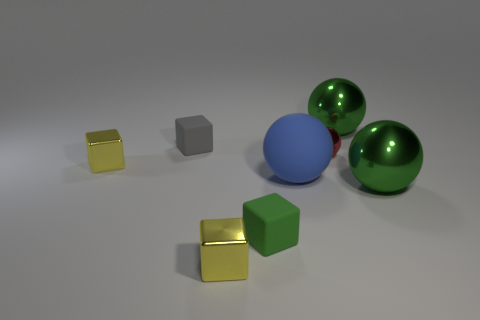What is the red sphere made of?
Your response must be concise. Metal. How many other things are there of the same size as the gray rubber thing?
Provide a succinct answer. 4. There is a yellow cube that is to the left of the small gray matte cube; what is its size?
Offer a very short reply. Small. There is a small yellow thing in front of the green ball that is in front of the blue rubber thing to the left of the red object; what is it made of?
Your answer should be very brief. Metal. Do the gray matte object and the green matte thing have the same shape?
Keep it short and to the point. Yes. What number of metallic things are either gray blocks or big spheres?
Keep it short and to the point. 2. What number of balls are there?
Keep it short and to the point. 4. There is another matte object that is the same size as the green rubber object; what is its color?
Your answer should be very brief. Gray. Do the green rubber thing and the red shiny object have the same size?
Provide a short and direct response. Yes. There is a gray matte block; is it the same size as the rubber ball that is on the left side of the red metallic object?
Provide a succinct answer. No. 